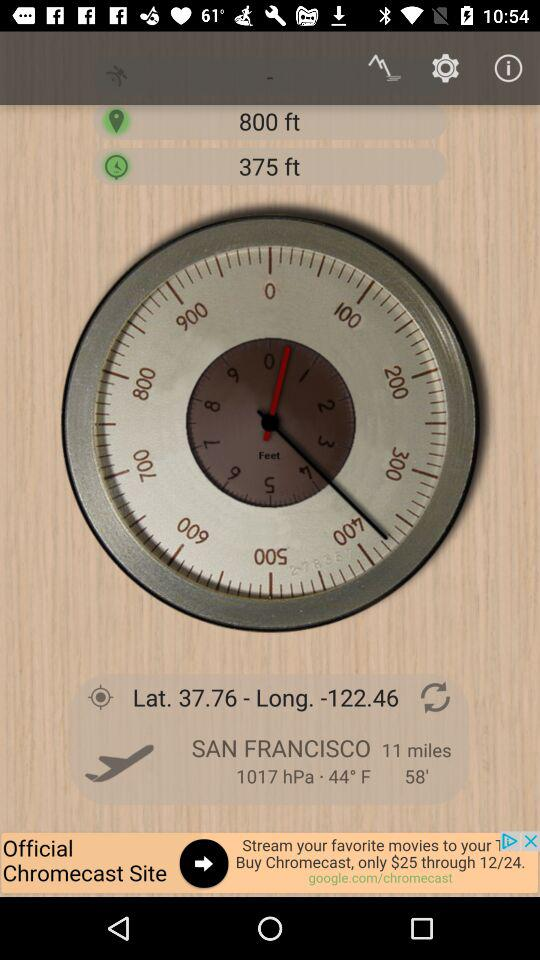How many miles are there? There are 11 miles. 